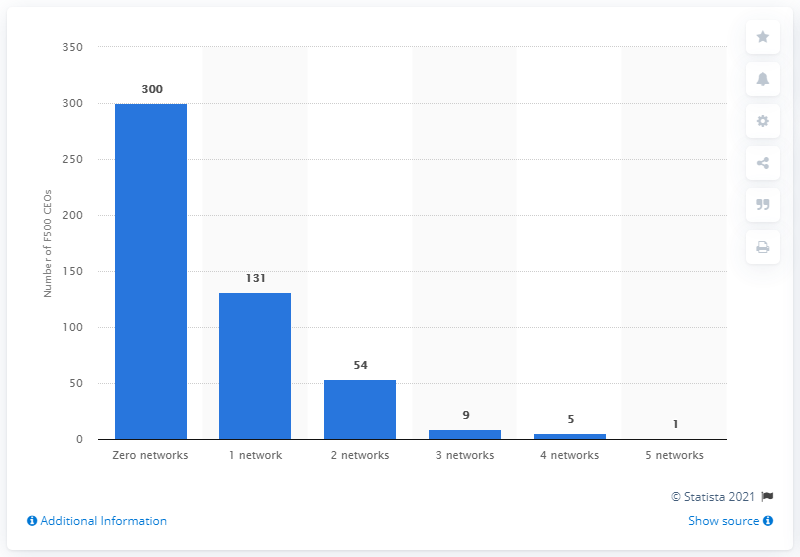How many CEOs had only one social media account?
 131 